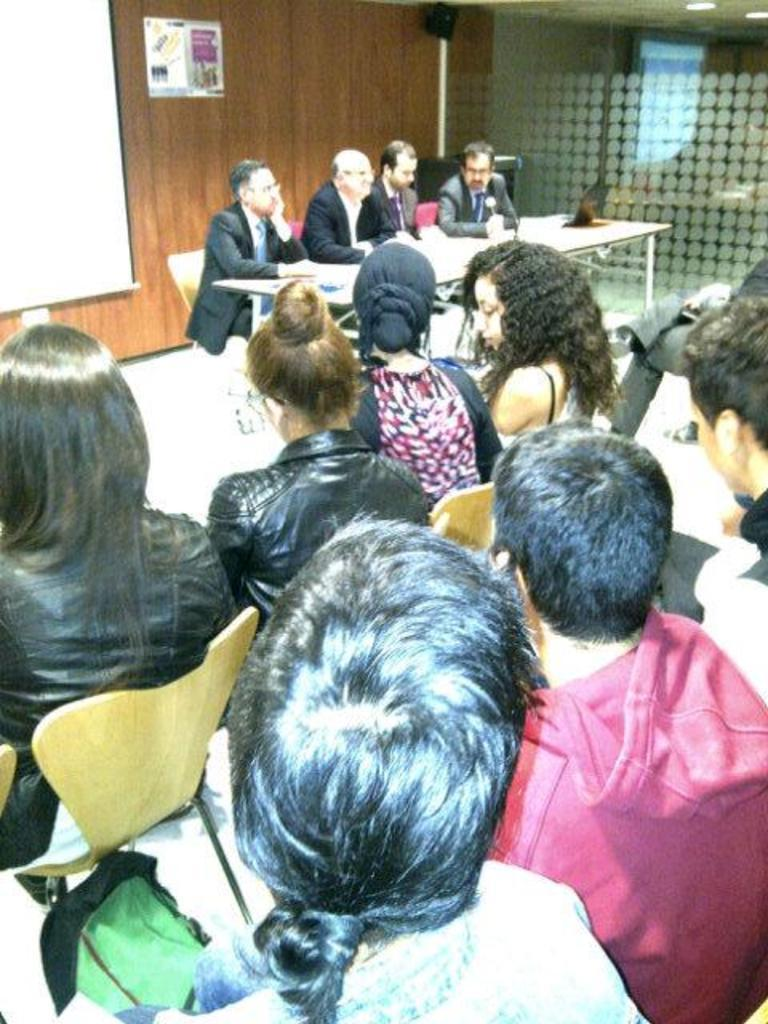What are the people in the image doing? The people in the image are sitting on chairs. What is present in the image besides the people? There is a table in the image. What can be seen in the background of the image? In the background of the image, there is a wall, glass, a ceiling, lights, a screen, and a poster. What is the person writing on the tongue in the image? There is no person writing on a tongue in the image. 